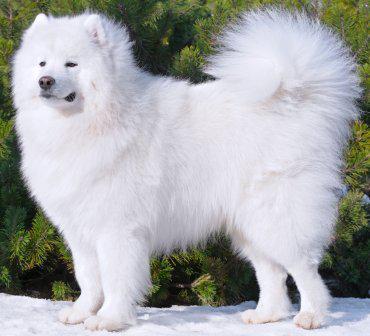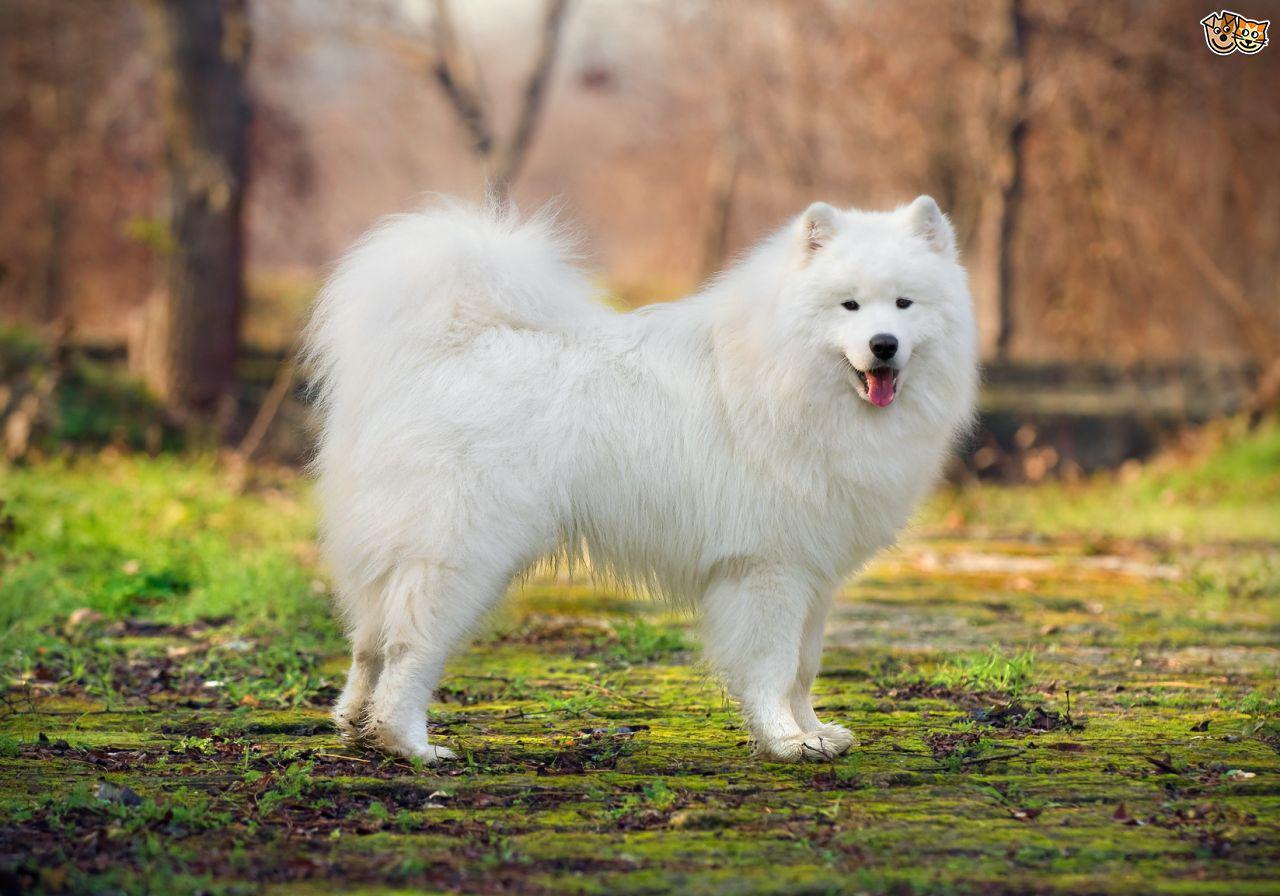The first image is the image on the left, the second image is the image on the right. For the images displayed, is the sentence "There are two white dogs standing outside." factually correct? Answer yes or no. Yes. 